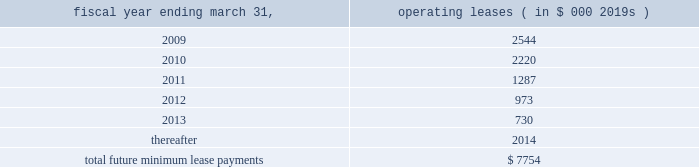Abiomed , inc .
And subsidiaries notes to consolidated financial statements 2014 ( continued ) note 15 .
Commitments and contingencies ( continued ) the company applies the disclosure provisions of fin no .
45 , guarantor 2019s accounting and disclosure requirements for guarantees , including guarantees of indebtedness of others , and interpretation of fasb statements no .
5 , 57 and 107 and rescission of fasb interpretation no .
34 ( fin no .
45 ) to its agreements that contain guarantee or indemnification clauses .
These disclosure provisions expand those required by sfas no .
5 , accounting for contingencies , by requiring that guarantors disclose certain types of guarantees , even if the likelihood of requiring the guarantor 2019s performance is remote .
In addition to product warranties , the following is a description of arrangements in which the company is a guarantor .
Indemnifications 2014in many sales transactions , the company indemnifies customers against possible claims of patent infringement caused by the company 2019s products .
The indemnifications contained within sales contracts usually do not include limits on the claims .
The company has never incurred any material costs to defend lawsuits or settle patent infringement claims related to sales transactions .
Under the provisions of fin no .
45 , intellectual property indemnifications require disclosure only .
The company enters into agreements with other companies in the ordinary course of business , typically with underwriters , contractors , clinical sites and customers that include indemnification provisions .
Under these provisions the company generally indemnifies and holds harmless the indemnified party for losses suffered or incurred by the indemnified party as a result of its activities .
These indemnification provisions generally survive termination of the underlying agreement .
The maximum potential amount of future payments the company could be required to make under these indemnification provisions is unlimited .
Abiomed has never incurred any material costs to defend lawsuits or settle claims related to these indemnification agreements .
As a result , the estimated fair value of these agreements is minimal .
Accordingly , the company has no liabilities recorded for these agreements as of march 31 , 2008 .
Clinical study agreements 2014in the company 2019s clinical study agreements , abiomed has agreed to indemnify the participating institutions against losses incurred by them for claims related to any personal injury of subjects taking part in the study to the extent they relate to uses of the company 2019s devices in accordance with the clinical study agreement , the protocol for the device and abiomed 2019s instructions .
The indemnification provisions contained within the company 2019s clinical study agreements do not generally include limits on the claims .
The company has never incurred any material costs related to the indemnification provisions contained in its clinical study agreements .
Facilities leases 2014as of march 31 , 2008 , the company had entered into leases for its facilities , including its primary operating facility in danvers , massachusetts with terms through fiscal 2010 .
The danvers lease may be extended , at the company 2019s option , for two successive additional periods of five years each with monthly rent charges to be determined based on then current fair rental values .
The company 2019s lease for its aachen location expires in december 2012 .
Total rent expense under these leases , included in the accompanying consolidated statements of operations approximated $ 2.2 million , $ 1.6 million , and $ 1.3 million for the fiscal years ended march 31 , 2008 , 2007 and 2006 , respectively .
Future minimum lease payments under all significant non-cancelable operating leases as of march 31 , 2008 are approximately as follows : fiscal year ending march 31 , operating leases ( in $ 000 2019s ) .
Litigation 2014from time-to-time , the company is involved in legal and administrative proceedings and claims of various types .
While any litigation contains an element of uncertainty , management presently believes that the outcome of each such other proceedings or claims which are pending or known to be threatened , or all of them combined , is not expected to have a material adverse effect on the company 2019s financial position , cash flow and results. .
What is the expected growth rate in operating leases in 2010 compare to 2009? 
Computations: ((2220 - 2544) / 2544)
Answer: -0.12736. 